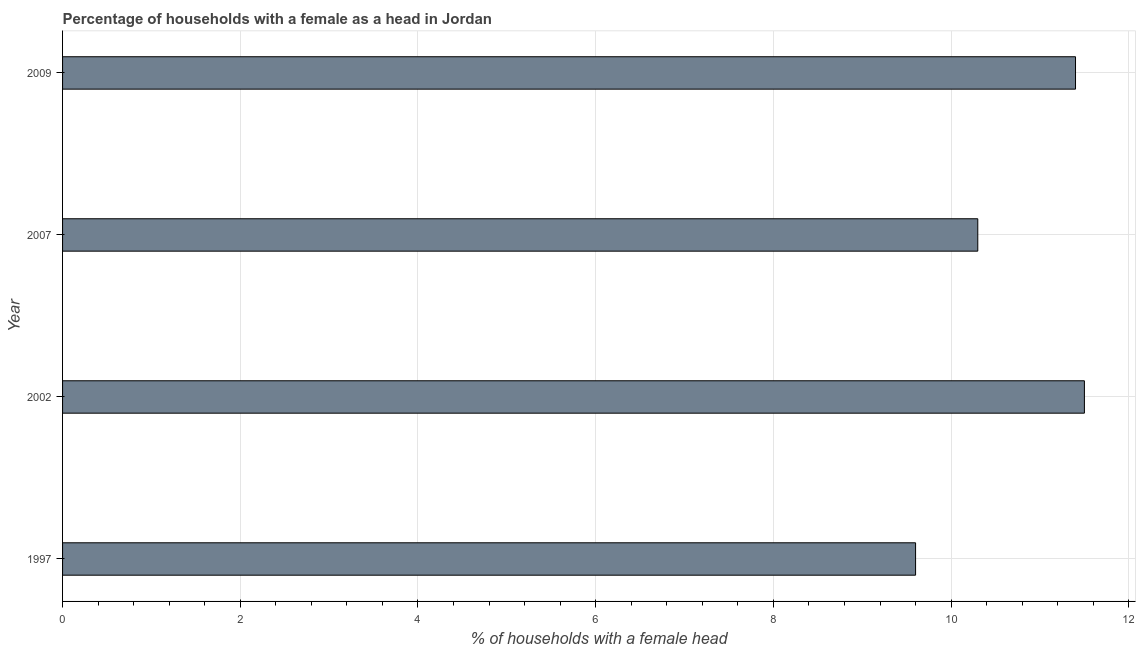Does the graph contain grids?
Provide a succinct answer. Yes. What is the title of the graph?
Provide a short and direct response. Percentage of households with a female as a head in Jordan. What is the label or title of the X-axis?
Your answer should be very brief. % of households with a female head. Across all years, what is the maximum number of female supervised households?
Keep it short and to the point. 11.5. Across all years, what is the minimum number of female supervised households?
Provide a short and direct response. 9.6. In which year was the number of female supervised households minimum?
Your response must be concise. 1997. What is the sum of the number of female supervised households?
Provide a short and direct response. 42.8. What is the difference between the number of female supervised households in 2002 and 2007?
Make the answer very short. 1.2. What is the average number of female supervised households per year?
Ensure brevity in your answer.  10.7. What is the median number of female supervised households?
Offer a terse response. 10.85. What is the ratio of the number of female supervised households in 2002 to that in 2009?
Provide a succinct answer. 1.01. What is the difference between the highest and the second highest number of female supervised households?
Provide a short and direct response. 0.1. Is the sum of the number of female supervised households in 1997 and 2009 greater than the maximum number of female supervised households across all years?
Offer a terse response. Yes. How many bars are there?
Provide a short and direct response. 4. Are all the bars in the graph horizontal?
Offer a terse response. Yes. What is the difference between two consecutive major ticks on the X-axis?
Your answer should be compact. 2. Are the values on the major ticks of X-axis written in scientific E-notation?
Make the answer very short. No. What is the % of households with a female head in 2009?
Provide a succinct answer. 11.4. What is the difference between the % of households with a female head in 1997 and 2002?
Give a very brief answer. -1.9. What is the difference between the % of households with a female head in 2002 and 2009?
Make the answer very short. 0.1. What is the difference between the % of households with a female head in 2007 and 2009?
Your answer should be very brief. -1.1. What is the ratio of the % of households with a female head in 1997 to that in 2002?
Your answer should be very brief. 0.83. What is the ratio of the % of households with a female head in 1997 to that in 2007?
Provide a short and direct response. 0.93. What is the ratio of the % of households with a female head in 1997 to that in 2009?
Your answer should be very brief. 0.84. What is the ratio of the % of households with a female head in 2002 to that in 2007?
Keep it short and to the point. 1.12. What is the ratio of the % of households with a female head in 2002 to that in 2009?
Offer a very short reply. 1.01. What is the ratio of the % of households with a female head in 2007 to that in 2009?
Give a very brief answer. 0.9. 